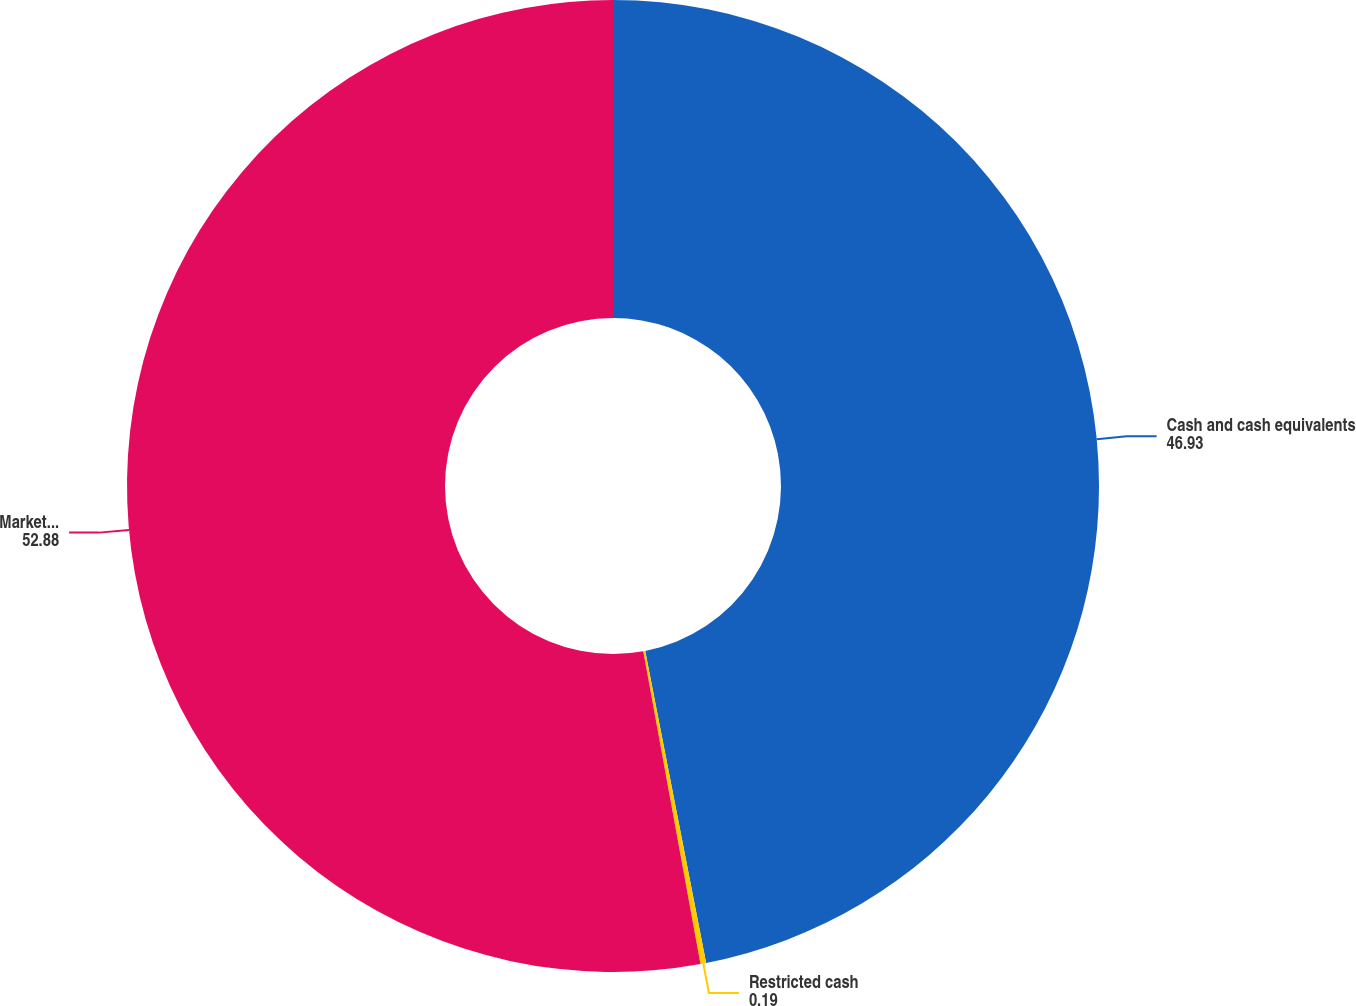<chart> <loc_0><loc_0><loc_500><loc_500><pie_chart><fcel>Cash and cash equivalents<fcel>Restricted cash<fcel>Marketable securities<nl><fcel>46.93%<fcel>0.19%<fcel>52.88%<nl></chart> 